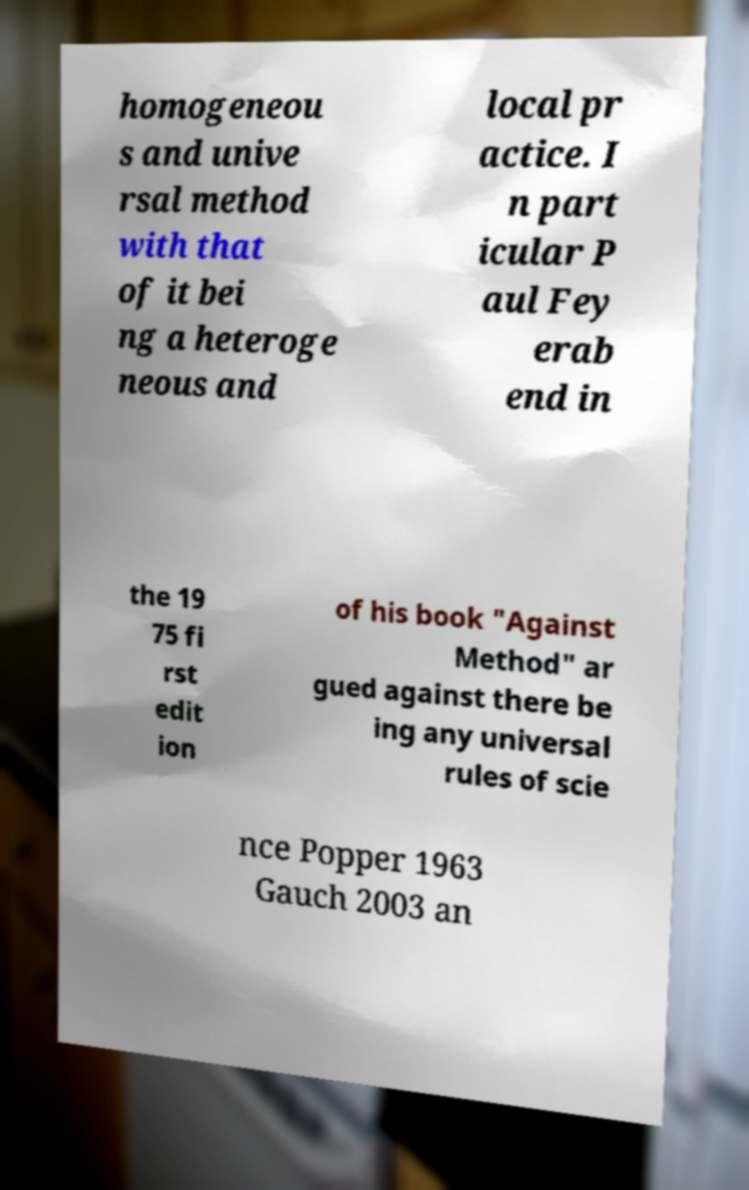What messages or text are displayed in this image? I need them in a readable, typed format. homogeneou s and unive rsal method with that of it bei ng a heteroge neous and local pr actice. I n part icular P aul Fey erab end in the 19 75 fi rst edit ion of his book "Against Method" ar gued against there be ing any universal rules of scie nce Popper 1963 Gauch 2003 an 